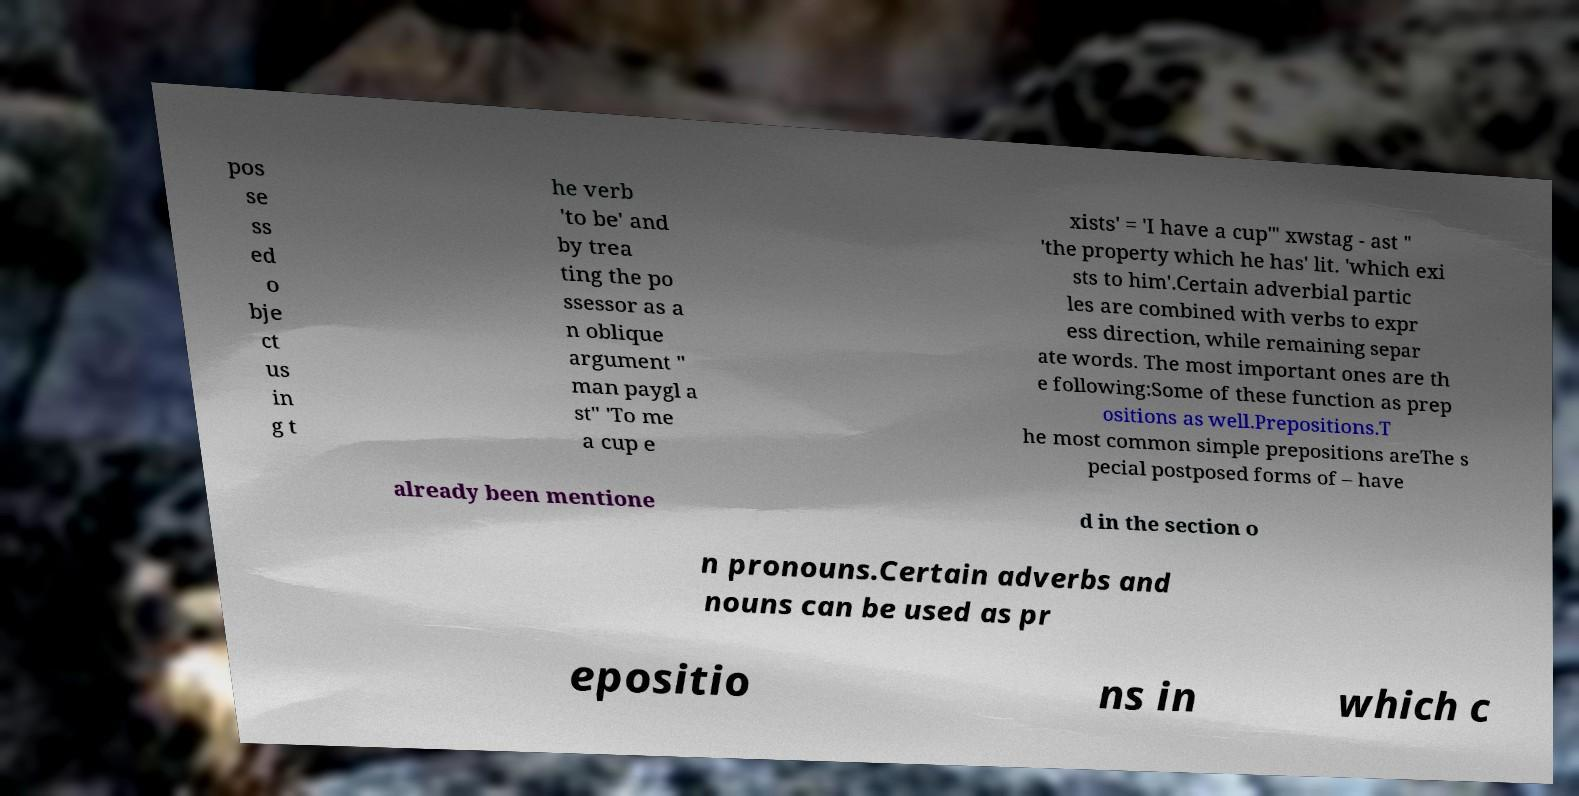For documentation purposes, I need the text within this image transcribed. Could you provide that? pos se ss ed o bje ct us in g t he verb 'to be' and by trea ting the po ssessor as a n oblique argument " man paygl a st" 'To me a cup e xists' = 'I have a cup'" xwstag - ast " 'the property which he has' lit. 'which exi sts to him'.Certain adverbial partic les are combined with verbs to expr ess direction, while remaining separ ate words. The most important ones are th e following:Some of these function as prep ositions as well.Prepositions.T he most common simple prepositions areThe s pecial postposed forms of – have already been mentione d in the section o n pronouns.Certain adverbs and nouns can be used as pr epositio ns in which c 